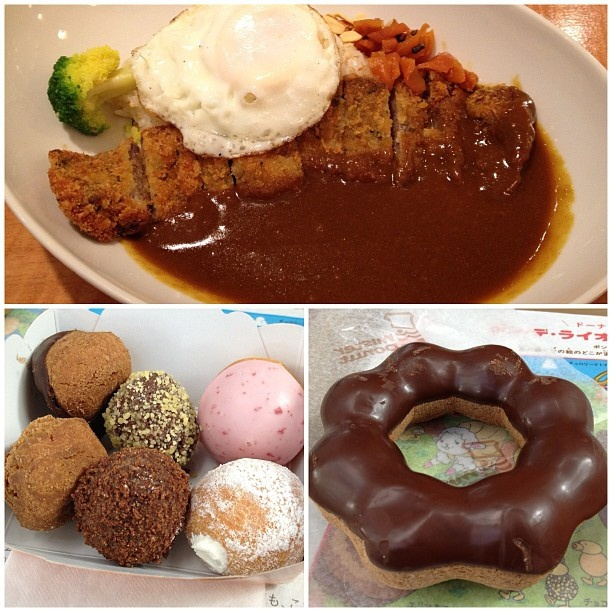Describe the objects in this image and their specific colors. I can see dining table in white, maroon, tan, and brown tones, bowl in white, maroon, tan, and brown tones, bowl in white, lightgray, maroon, gray, and brown tones, donut in white, maroon, brown, and black tones, and donut in white, ivory, and tan tones in this image. 